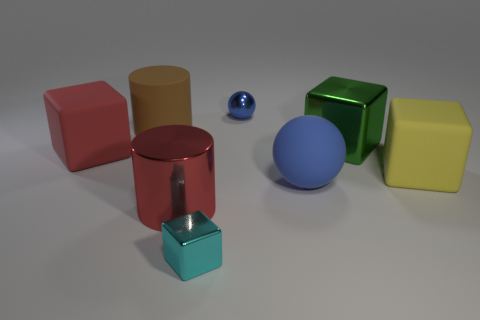Add 1 big brown things. How many objects exist? 9 Subtract all spheres. How many objects are left? 6 Subtract 1 red cubes. How many objects are left? 7 Subtract all large red matte blocks. Subtract all small blue shiny objects. How many objects are left? 6 Add 7 large red matte objects. How many large red matte objects are left? 8 Add 1 big cyan metallic cubes. How many big cyan metallic cubes exist? 1 